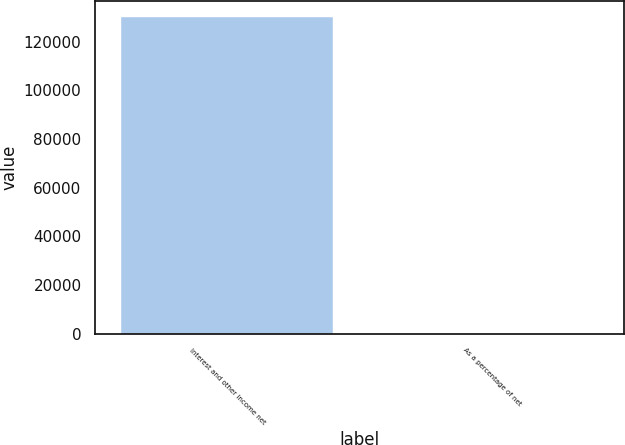Convert chart. <chart><loc_0><loc_0><loc_500><loc_500><bar_chart><fcel>Interest and other income net<fcel>As a percentage of net<nl><fcel>130021<fcel>2.2<nl></chart> 